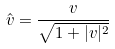<formula> <loc_0><loc_0><loc_500><loc_500>\hat { v } = \frac { v } { \sqrt { 1 + | v | ^ { 2 } } }</formula> 